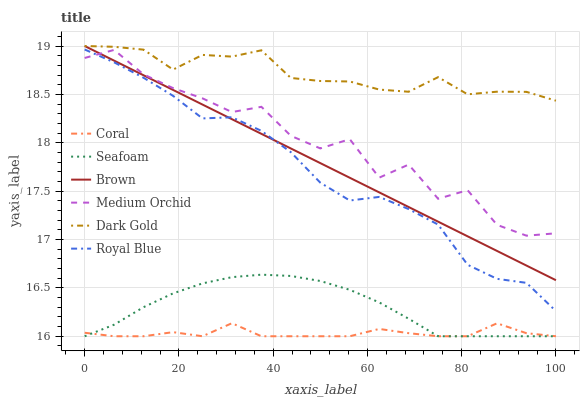Does Coral have the minimum area under the curve?
Answer yes or no. Yes. Does Dark Gold have the maximum area under the curve?
Answer yes or no. Yes. Does Dark Gold have the minimum area under the curve?
Answer yes or no. No. Does Coral have the maximum area under the curve?
Answer yes or no. No. Is Brown the smoothest?
Answer yes or no. Yes. Is Medium Orchid the roughest?
Answer yes or no. Yes. Is Dark Gold the smoothest?
Answer yes or no. No. Is Dark Gold the roughest?
Answer yes or no. No. Does Coral have the lowest value?
Answer yes or no. Yes. Does Dark Gold have the lowest value?
Answer yes or no. No. Does Dark Gold have the highest value?
Answer yes or no. Yes. Does Coral have the highest value?
Answer yes or no. No. Is Seafoam less than Royal Blue?
Answer yes or no. Yes. Is Royal Blue greater than Seafoam?
Answer yes or no. Yes. Does Medium Orchid intersect Brown?
Answer yes or no. Yes. Is Medium Orchid less than Brown?
Answer yes or no. No. Is Medium Orchid greater than Brown?
Answer yes or no. No. Does Seafoam intersect Royal Blue?
Answer yes or no. No. 